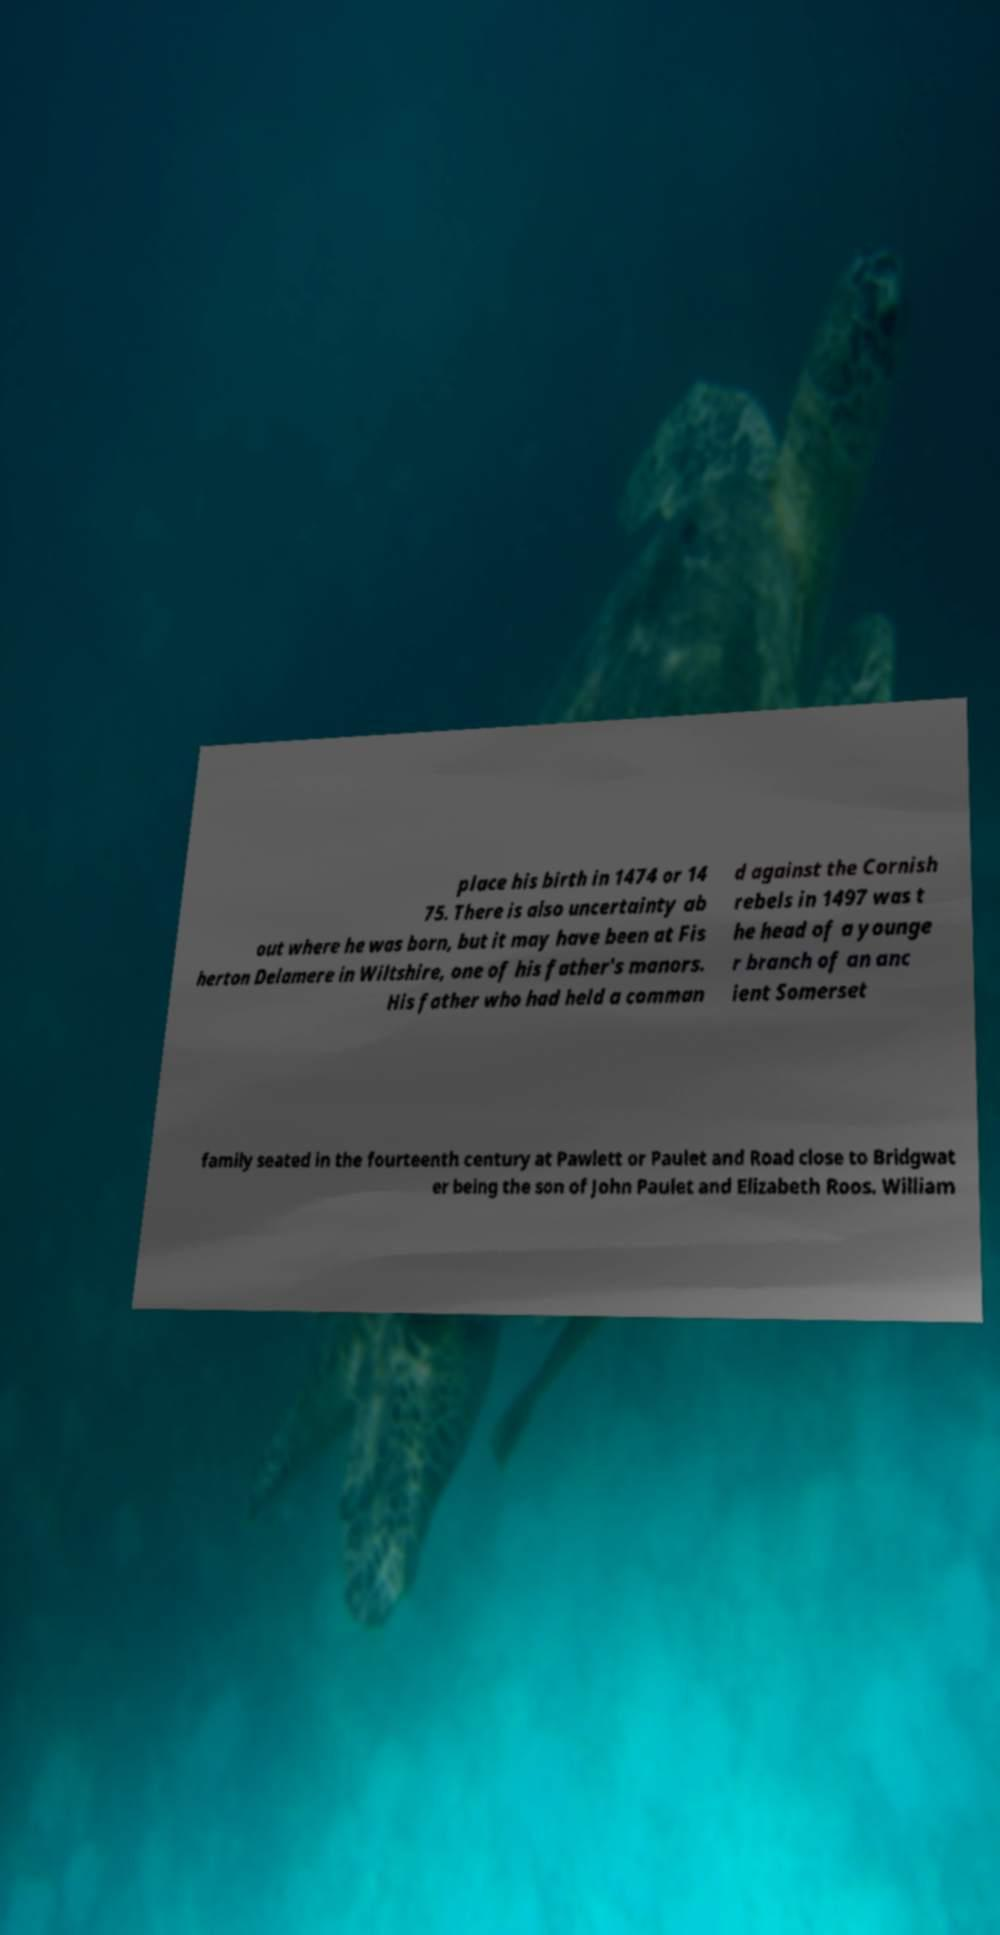Could you extract and type out the text from this image? place his birth in 1474 or 14 75. There is also uncertainty ab out where he was born, but it may have been at Fis herton Delamere in Wiltshire, one of his father's manors. His father who had held a comman d against the Cornish rebels in 1497 was t he head of a younge r branch of an anc ient Somerset family seated in the fourteenth century at Pawlett or Paulet and Road close to Bridgwat er being the son of John Paulet and Elizabeth Roos. William 